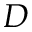<formula> <loc_0><loc_0><loc_500><loc_500>D</formula> 